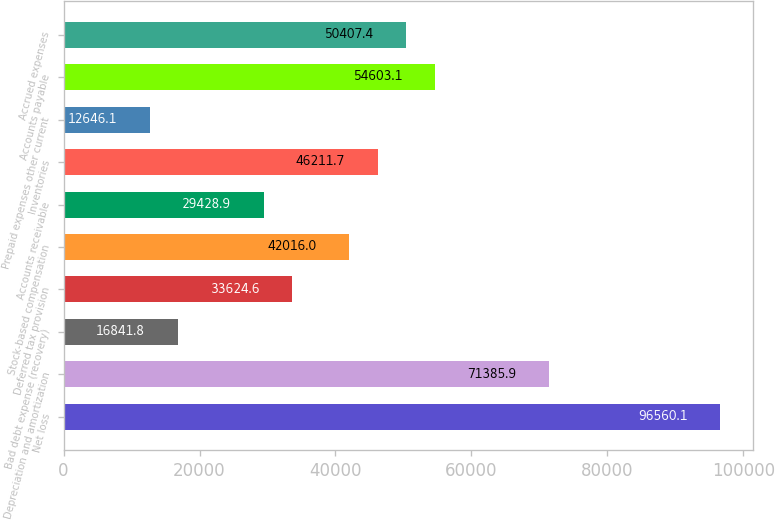Convert chart to OTSL. <chart><loc_0><loc_0><loc_500><loc_500><bar_chart><fcel>Net loss<fcel>Depreciation and amortization<fcel>Bad debt expense (recovery)<fcel>Deferred tax provision<fcel>Stock-based compensation<fcel>Accounts receivable<fcel>Inventories<fcel>Prepaid expenses other current<fcel>Accounts payable<fcel>Accrued expenses<nl><fcel>96560.1<fcel>71385.9<fcel>16841.8<fcel>33624.6<fcel>42016<fcel>29428.9<fcel>46211.7<fcel>12646.1<fcel>54603.1<fcel>50407.4<nl></chart> 